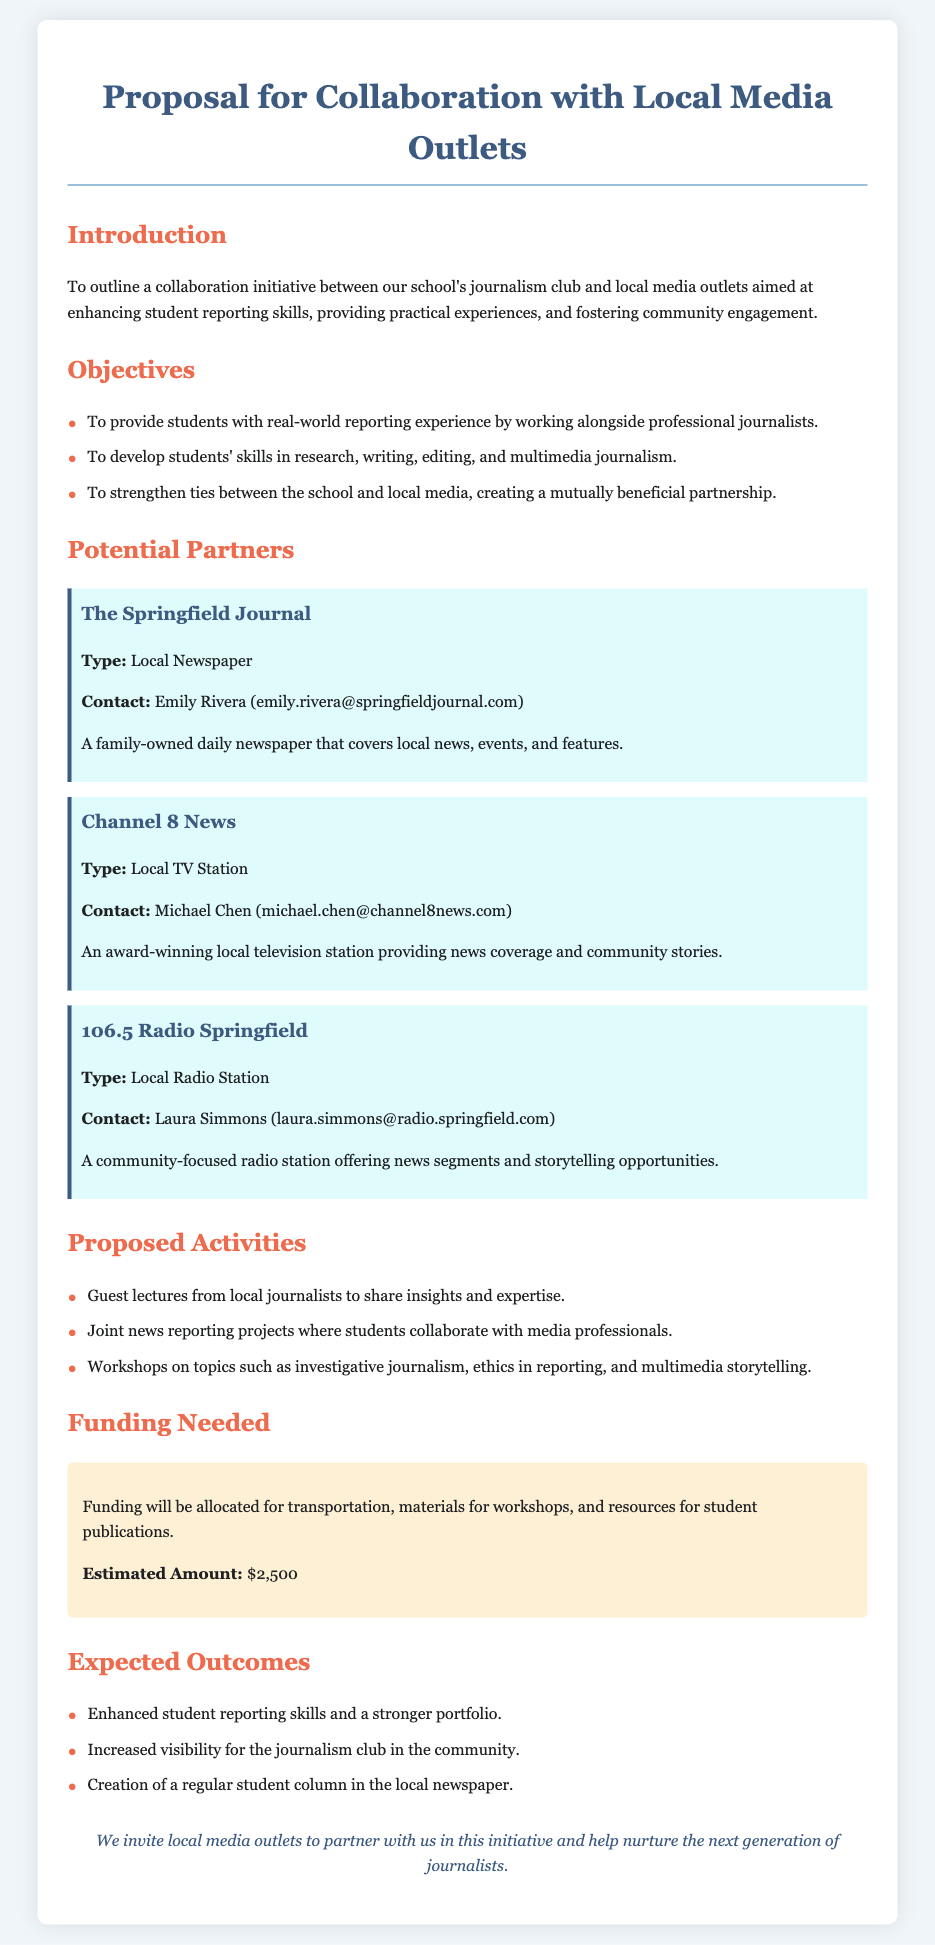What is the purpose of the collaboration? The purpose is to outline a collaboration initiative between the school's journalism club and local media outlets aimed at enhancing student reporting skills, providing practical experiences, and fostering community engagement.
Answer: Enhance student reporting skills Who is the contact for Channel 8 News? The contact information for Channel 8 News is provided in the document under the partner section.
Answer: Michael Chen (michael.chen@channel8news.com) What is the estimated funding amount needed? The document specifies the funding needed and the estimated amount required for the collaboration.
Answer: $2,500 What type of activities will students participate in? The proposed activities outlined in the document include guest lectures, joint news reporting projects, and workshops.
Answer: Workshops Which local newspaper is mentioned as a potential partner? The document lists potential partners, and the local newspaper is specifically identified as one of them.
Answer: The Springfield Journal What are the expected outcomes of this collaboration? The outcomes include enhanced student reporting skills, increased visibility for the journalism club, and the creation of a student column.
Answer: Enhanced student reporting skills and a stronger portfolio What is the overall goal of the partnership? The overall goal is to create a mutually beneficial partnership between the school and local media.
Answer: Strengthen ties between the school and local media What type of journalistic skills will be developed? The document outlines specific skills that students will develop through the collaboration.
Answer: Research, writing, editing, and multimedia journalism 